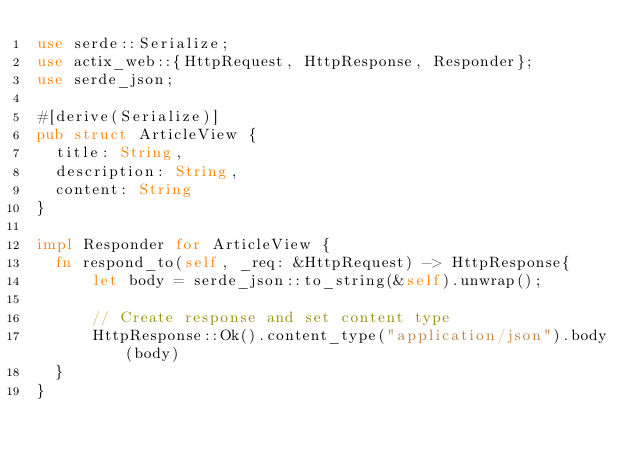Convert code to text. <code><loc_0><loc_0><loc_500><loc_500><_Rust_>use serde::Serialize;
use actix_web::{HttpRequest, HttpResponse, Responder};
use serde_json;

#[derive(Serialize)]
pub struct ArticleView {
  title: String,
  description: String,
  content: String
}

impl Responder for ArticleView {
  fn respond_to(self, _req: &HttpRequest) -> HttpResponse{
      let body = serde_json::to_string(&self).unwrap();

      // Create response and set content type
      HttpResponse::Ok().content_type("application/json").body(body)
  }
}


</code> 